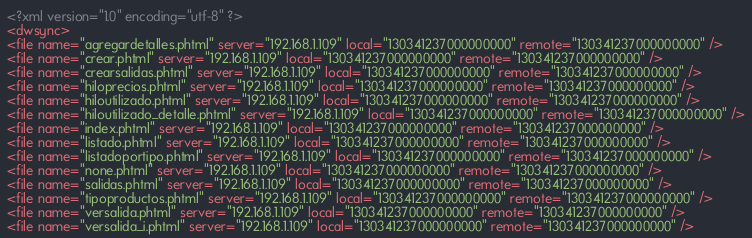<code> <loc_0><loc_0><loc_500><loc_500><_XML_><?xml version="1.0" encoding="utf-8" ?>
<dwsync>
<file name="agregardetalles.phtml" server="192.168.1.109" local="130341237000000000" remote="130341237000000000" />
<file name="crear.phtml" server="192.168.1.109" local="130341237000000000" remote="130341237000000000" />
<file name="crearsalidas.phtml" server="192.168.1.109" local="130341237000000000" remote="130341237000000000" />
<file name="hiloprecios.phtml" server="192.168.1.109" local="130341237000000000" remote="130341237000000000" />
<file name="hiloutilizado.phtml" server="192.168.1.109" local="130341237000000000" remote="130341237000000000" />
<file name="hiloutilizado_detalle.phtml" server="192.168.1.109" local="130341237000000000" remote="130341237000000000" />
<file name="index.phtml" server="192.168.1.109" local="130341237000000000" remote="130341237000000000" />
<file name="listado.phtml" server="192.168.1.109" local="130341237000000000" remote="130341237000000000" />
<file name="listadoportipo.phtml" server="192.168.1.109" local="130341237000000000" remote="130341237000000000" />
<file name="none.phtml" server="192.168.1.109" local="130341237000000000" remote="130341237000000000" />
<file name="salidas.phtml" server="192.168.1.109" local="130341237000000000" remote="130341237000000000" />
<file name="tipoproductos.phtml" server="192.168.1.109" local="130341237000000000" remote="130341237000000000" />
<file name="versalida.phtml" server="192.168.1.109" local="130341237000000000" remote="130341237000000000" />
<file name="versalida_i.phtml" server="192.168.1.109" local="130341237000000000" remote="130341237000000000" /></code> 